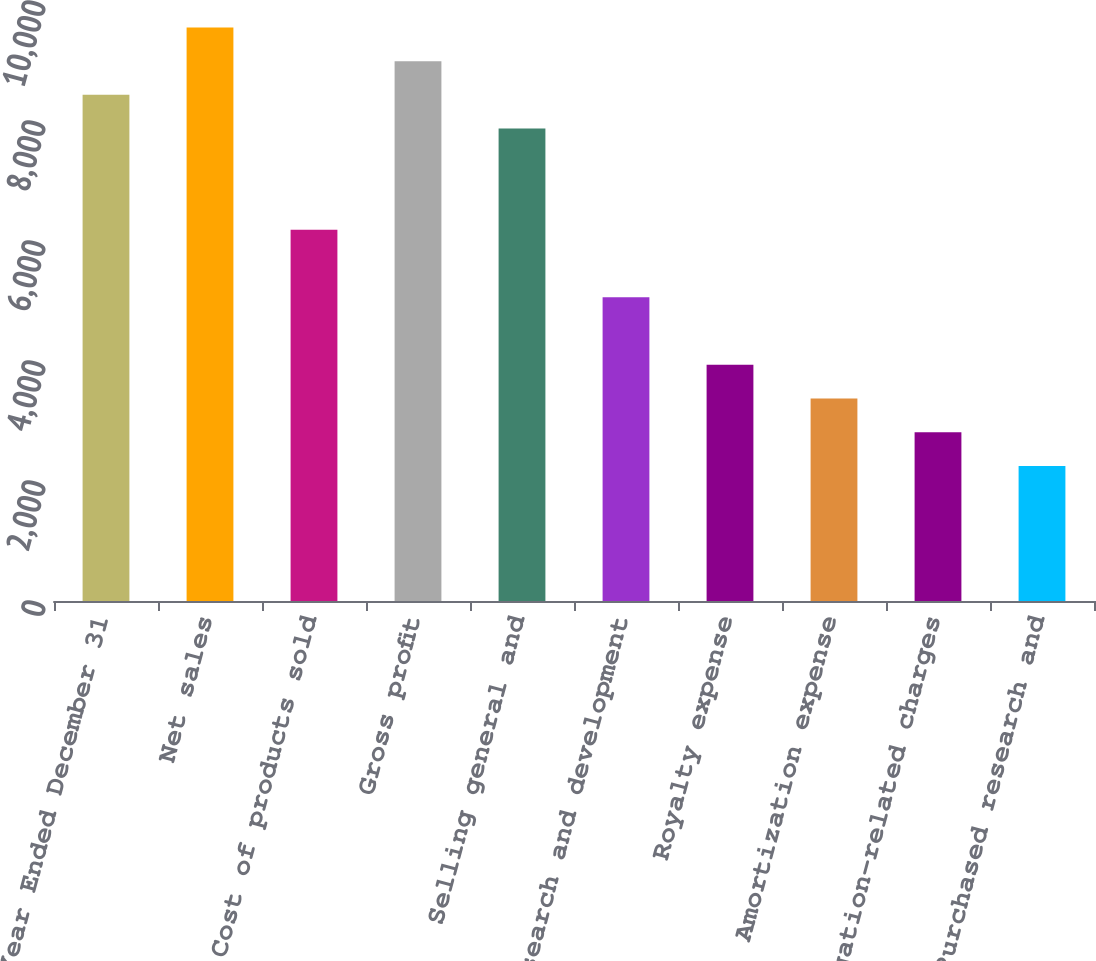Convert chart to OTSL. <chart><loc_0><loc_0><loc_500><loc_500><bar_chart><fcel>Year Ended December 31<fcel>Net sales<fcel>Cost of products sold<fcel>Gross profit<fcel>Selling general and<fcel>Research and development<fcel>Royalty expense<fcel>Amortization expense<fcel>Litigation-related charges<fcel>Purchased research and<nl><fcel>8435.44<fcel>9560<fcel>6186.32<fcel>8997.72<fcel>7873.16<fcel>5061.76<fcel>3937.2<fcel>3374.92<fcel>2812.64<fcel>2250.36<nl></chart> 